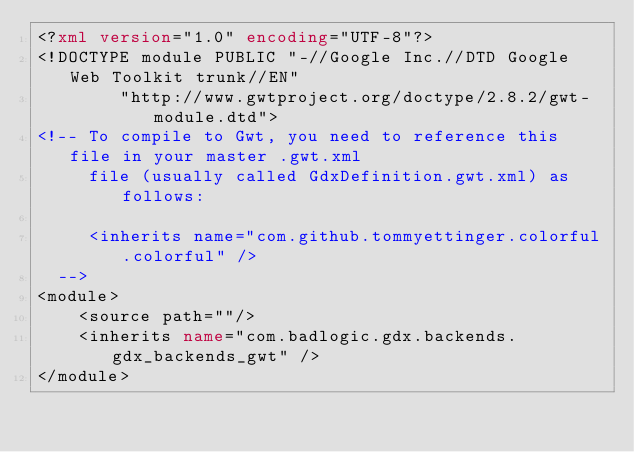Convert code to text. <code><loc_0><loc_0><loc_500><loc_500><_XML_><?xml version="1.0" encoding="UTF-8"?>
<!DOCTYPE module PUBLIC "-//Google Inc.//DTD Google Web Toolkit trunk//EN"
        "http://www.gwtproject.org/doctype/2.8.2/gwt-module.dtd">
<!-- To compile to Gwt, you need to reference this file in your master .gwt.xml
     file (usually called GdxDefinition.gwt.xml) as follows:

     <inherits name="com.github.tommyettinger.colorful.colorful" />
  -->
<module>
    <source path=""/>
    <inherits name="com.badlogic.gdx.backends.gdx_backends_gwt" />
</module>
</code> 